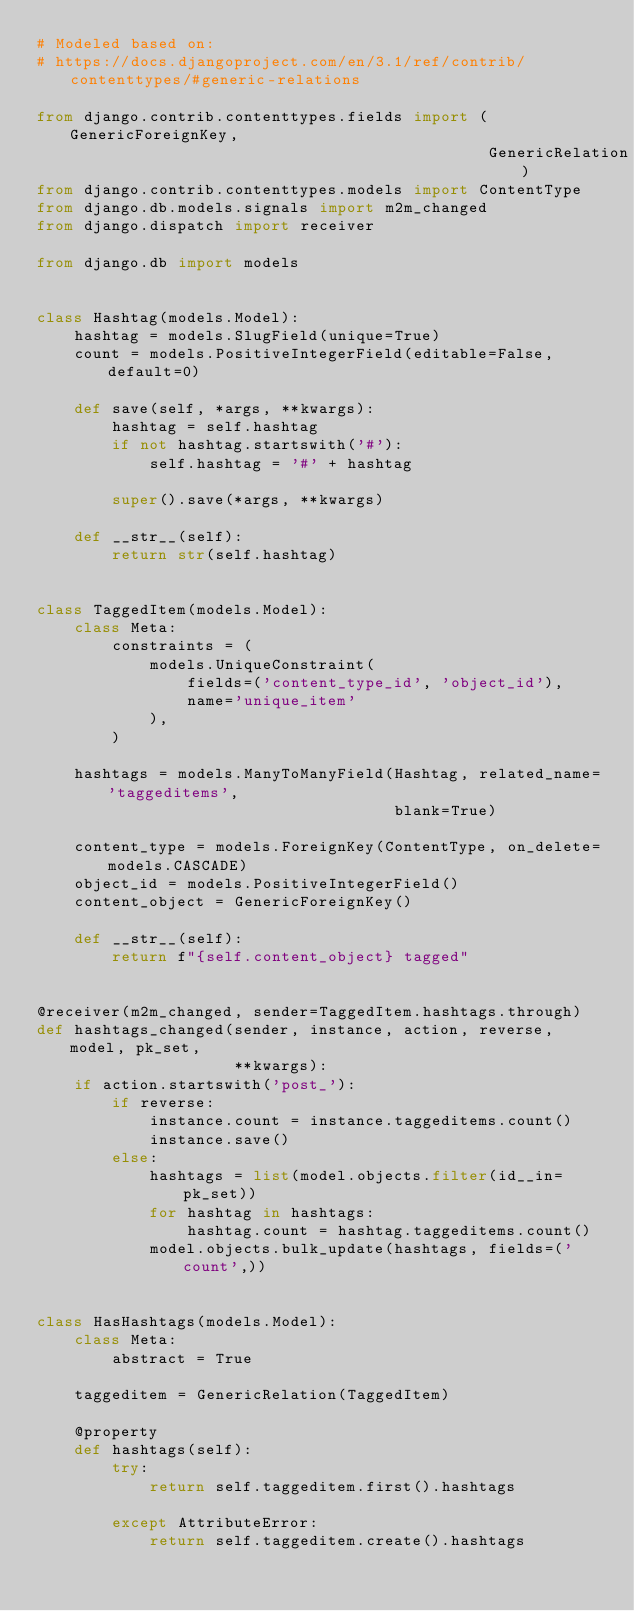Convert code to text. <code><loc_0><loc_0><loc_500><loc_500><_Python_># Modeled based on:
# https://docs.djangoproject.com/en/3.1/ref/contrib/contenttypes/#generic-relations

from django.contrib.contenttypes.fields import (GenericForeignKey,
                                                GenericRelation)
from django.contrib.contenttypes.models import ContentType
from django.db.models.signals import m2m_changed
from django.dispatch import receiver

from django.db import models


class Hashtag(models.Model):
    hashtag = models.SlugField(unique=True)
    count = models.PositiveIntegerField(editable=False, default=0)

    def save(self, *args, **kwargs):
        hashtag = self.hashtag
        if not hashtag.startswith('#'):
            self.hashtag = '#' + hashtag

        super().save(*args, **kwargs)

    def __str__(self):
        return str(self.hashtag)


class TaggedItem(models.Model):
    class Meta:
        constraints = (
            models.UniqueConstraint(
                fields=('content_type_id', 'object_id'),
                name='unique_item'
            ),
        )

    hashtags = models.ManyToManyField(Hashtag, related_name='taggeditems',
                                      blank=True)

    content_type = models.ForeignKey(ContentType, on_delete=models.CASCADE)
    object_id = models.PositiveIntegerField()
    content_object = GenericForeignKey()

    def __str__(self):
        return f"{self.content_object} tagged"


@receiver(m2m_changed, sender=TaggedItem.hashtags.through)
def hashtags_changed(sender, instance, action, reverse, model, pk_set,
                     **kwargs):
    if action.startswith('post_'):
        if reverse:
            instance.count = instance.taggeditems.count()
            instance.save()
        else:
            hashtags = list(model.objects.filter(id__in=pk_set))
            for hashtag in hashtags:
                hashtag.count = hashtag.taggeditems.count()
            model.objects.bulk_update(hashtags, fields=('count',))


class HasHashtags(models.Model):
    class Meta:
        abstract = True

    taggeditem = GenericRelation(TaggedItem)

    @property
    def hashtags(self):
        try:
            return self.taggeditem.first().hashtags

        except AttributeError:
            return self.taggeditem.create().hashtags
</code> 